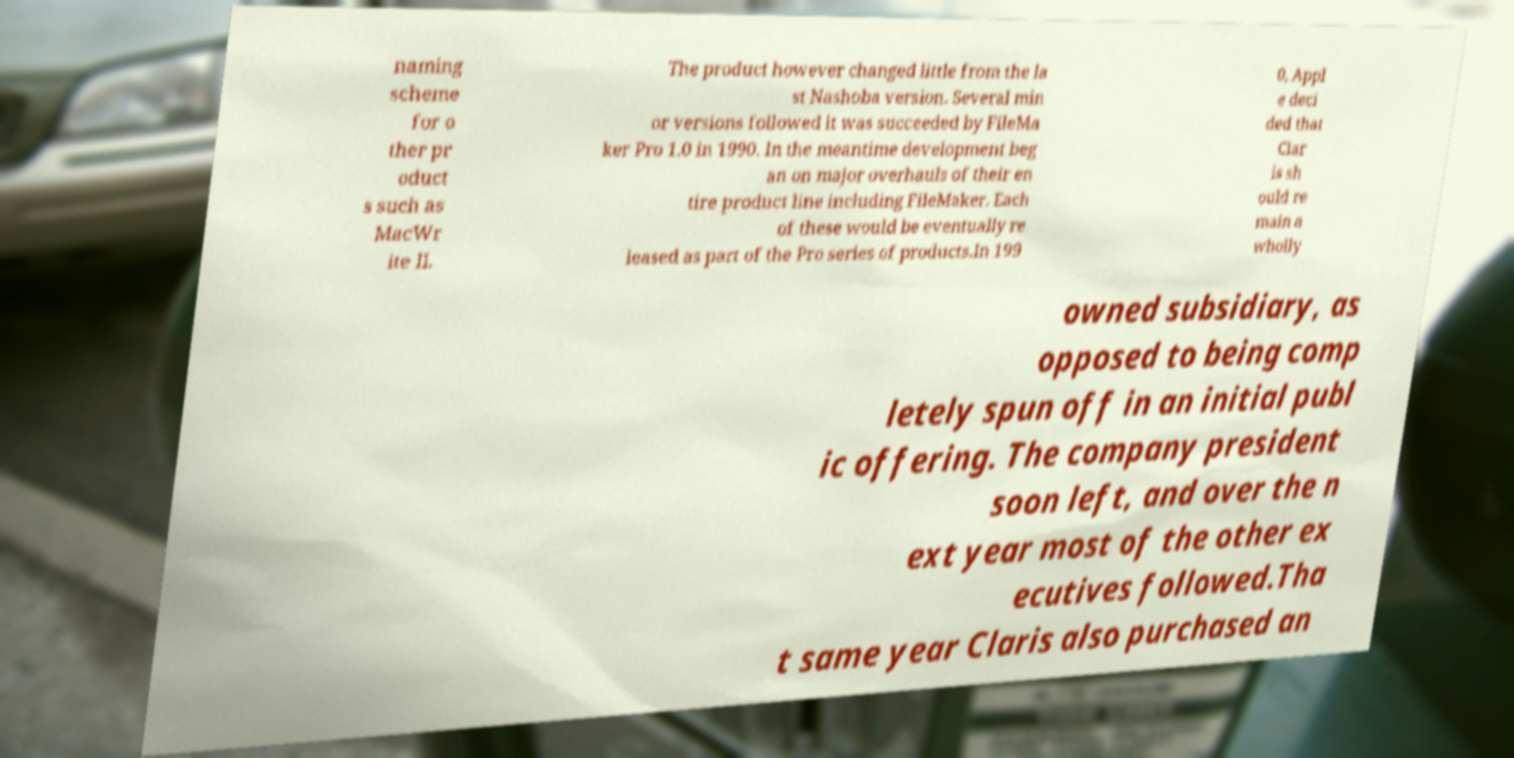Please read and relay the text visible in this image. What does it say? naming scheme for o ther pr oduct s such as MacWr ite II. The product however changed little from the la st Nashoba version. Several min or versions followed it was succeeded by FileMa ker Pro 1.0 in 1990. In the meantime development beg an on major overhauls of their en tire product line including FileMaker. Each of these would be eventually re leased as part of the Pro series of products.In 199 0, Appl e deci ded that Clar is sh ould re main a wholly owned subsidiary, as opposed to being comp letely spun off in an initial publ ic offering. The company president soon left, and over the n ext year most of the other ex ecutives followed.Tha t same year Claris also purchased an 